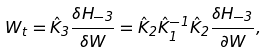<formula> <loc_0><loc_0><loc_500><loc_500>W _ { t } = \hat { K } _ { 3 } \frac { \delta H _ { - 3 } } { \delta W } = \hat { K } _ { 2 } \hat { K } _ { 1 } ^ { - 1 } \hat { K } _ { 2 } \frac { \delta H _ { - 3 } } { \partial W } ,</formula> 